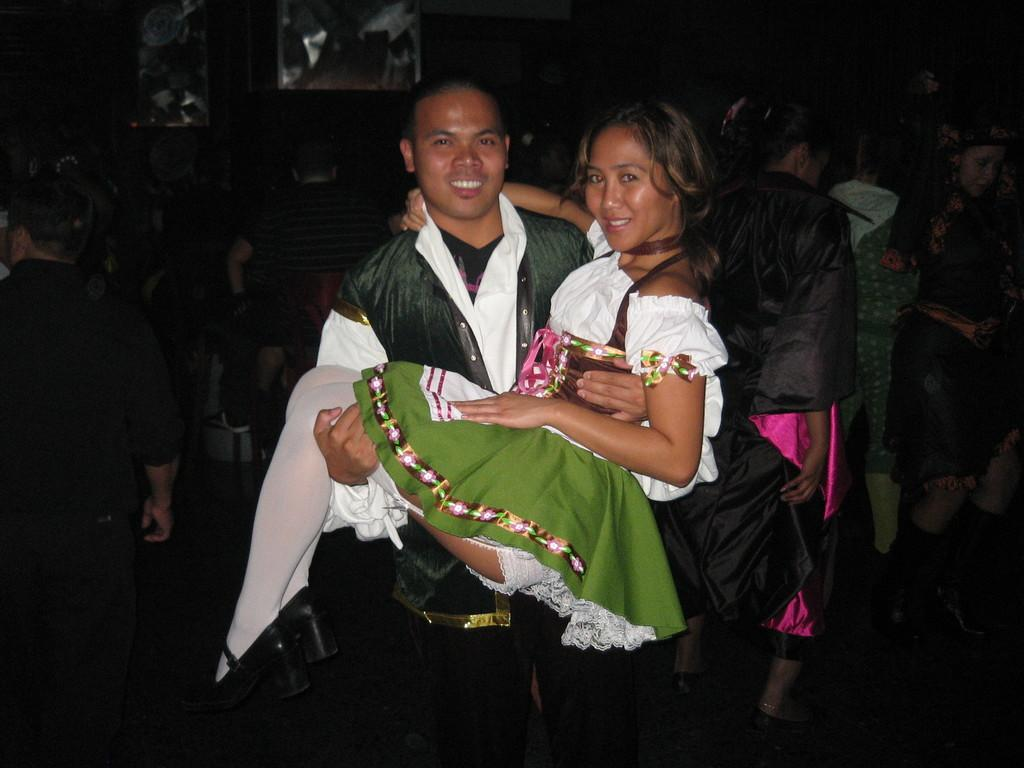Who is the main subject in the image? There is a man in the image. What is the man doing in the image? The man is lifting a girl in the image. Can you describe the background of the image? There are people in the background of the image. How many balloons are being traded between the man and the girl in the image? There are no balloons present in the image, and no trade is taking place between the man and the girl. 